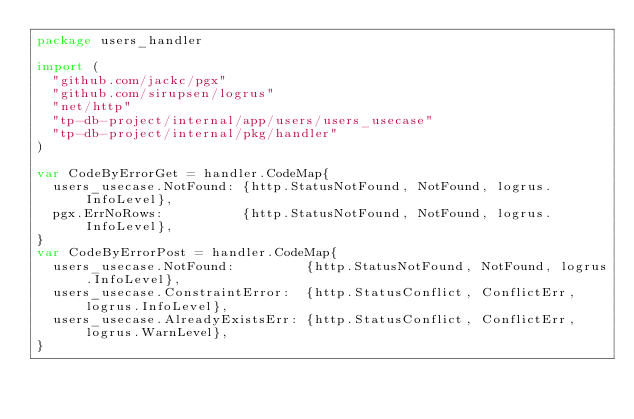Convert code to text. <code><loc_0><loc_0><loc_500><loc_500><_Go_>package users_handler

import (
	"github.com/jackc/pgx"
	"github.com/sirupsen/logrus"
	"net/http"
	"tp-db-project/internal/app/users/users_usecase"
	"tp-db-project/internal/pkg/handler"
)

var CodeByErrorGet = handler.CodeMap{
	users_usecase.NotFound: {http.StatusNotFound, NotFound, logrus.InfoLevel},
	pgx.ErrNoRows:          {http.StatusNotFound, NotFound, logrus.InfoLevel},
}
var CodeByErrorPost = handler.CodeMap{
	users_usecase.NotFound:         {http.StatusNotFound, NotFound, logrus.InfoLevel},
	users_usecase.ConstraintError:  {http.StatusConflict, ConflictErr, logrus.InfoLevel},
	users_usecase.AlreadyExistsErr: {http.StatusConflict, ConflictErr, logrus.WarnLevel},
}
</code> 